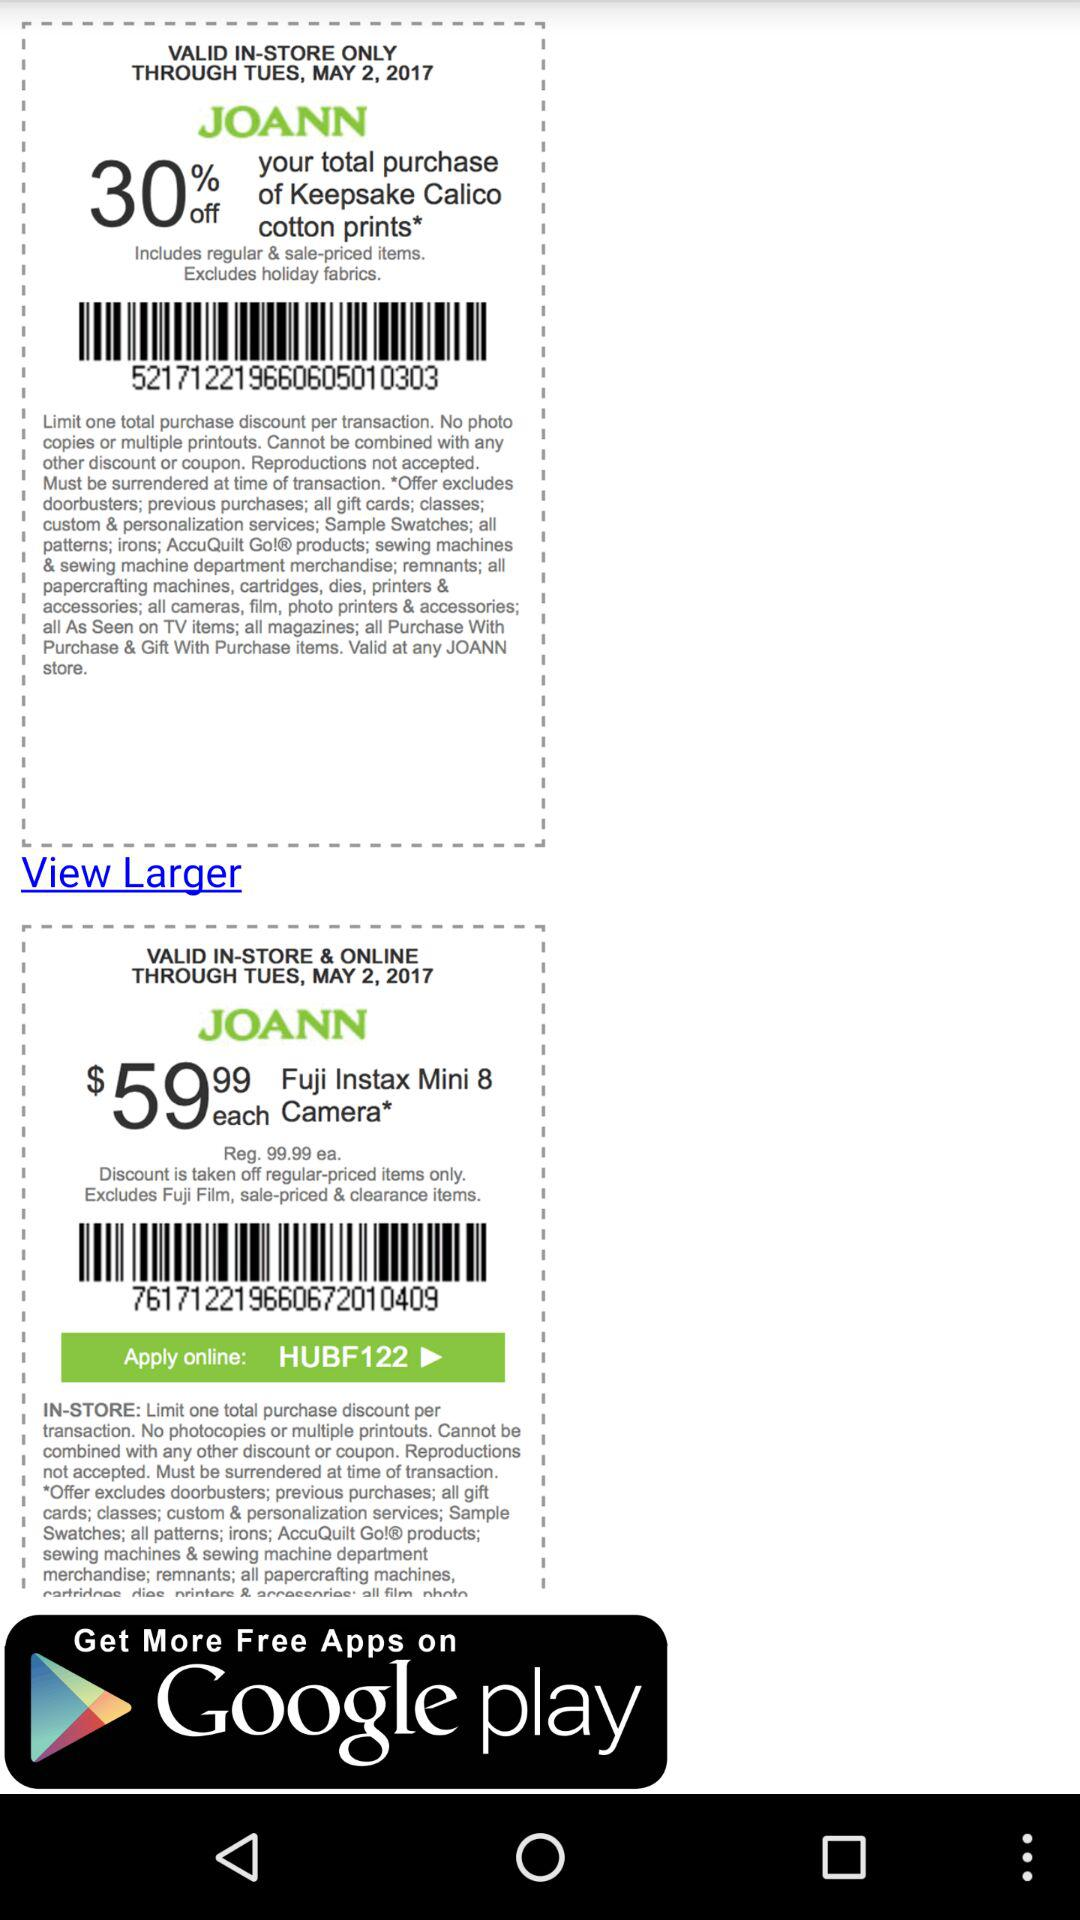Until what date is the in-store coupon valid? The in-store coupon is valid until Tuesday, May 2, 2017. 